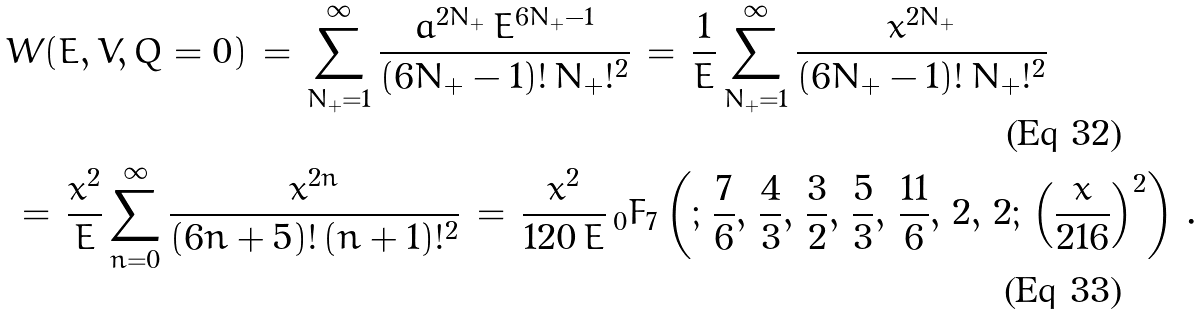<formula> <loc_0><loc_0><loc_500><loc_500>& W ( E , V , Q = 0 ) \, = \, \sum _ { N _ { + } = 1 } ^ { \infty } \frac { a ^ { 2 N _ { + } } \, E ^ { 6 N _ { + } - 1 } } { ( 6 N _ { + } - 1 ) ! \, N _ { + } ! ^ { 2 } } \, = \, \frac { 1 } { E } \sum _ { N _ { + } = 1 } ^ { \infty } \frac { x ^ { 2 N _ { + } } } { ( 6 N _ { + } - 1 ) ! \, N _ { + } ! ^ { 2 } } \\ & \, = \, \frac { x ^ { 2 } } { E } \sum _ { n = 0 } ^ { \infty } \frac { x ^ { 2 n } } { ( 6 n + 5 ) ! \, ( n + 1 ) ! ^ { 2 } } \, = \, \frac { x ^ { 2 } } { 1 2 0 \, E } \, _ { 0 } F _ { 7 } \left ( ; \, \frac { 7 } { 6 } , \, \frac { 4 } { 3 } , \, \frac { 3 } { 2 } , \, \frac { 5 } { 3 } , \, \frac { 1 1 } { 6 } , \, 2 , \, 2 ; \, \left ( \frac { x } { 2 1 6 } \right ) ^ { 2 } \right ) \, .</formula> 